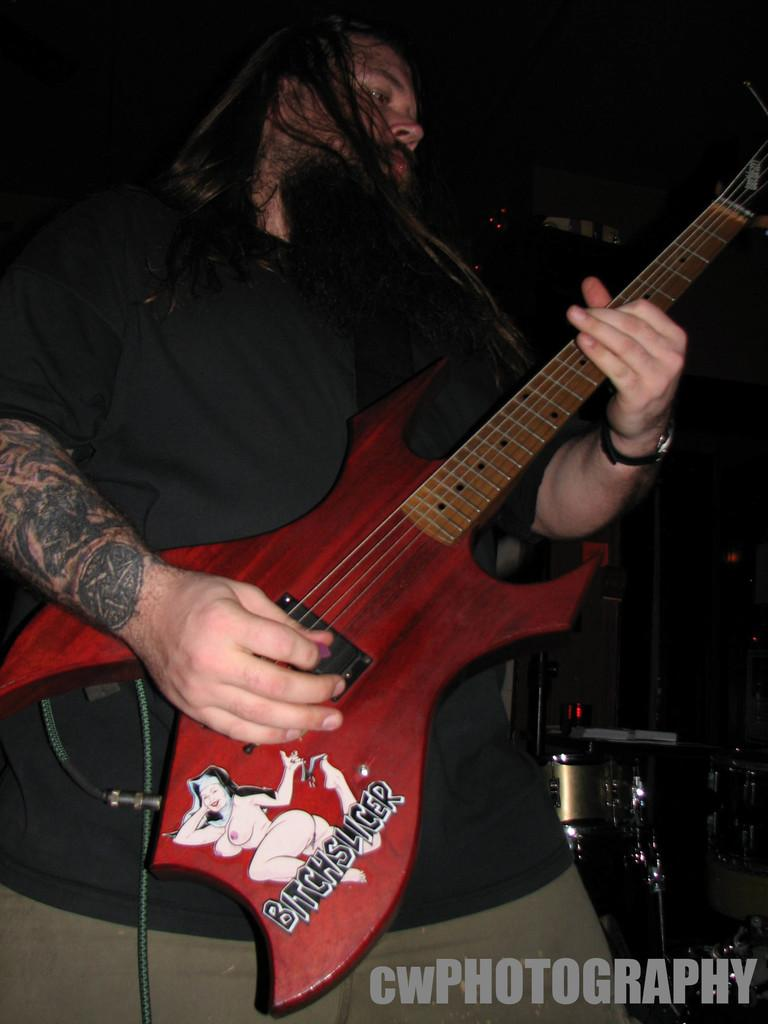What is the person in the image doing? The person is standing and playing a red guitar. What can be seen on the guitar? The guitar has "bitchslap" written on it. What is the person wearing? The person is wearing a black t-shirt. What other musical instrument is visible in the image? There are drums visible in the image. Where are the drums located in relation to the person? The drums are located to the right of the person. What type of approval is the person seeking from the train in the image? There is no train present in the image, so the person cannot be seeking approval from a train. 